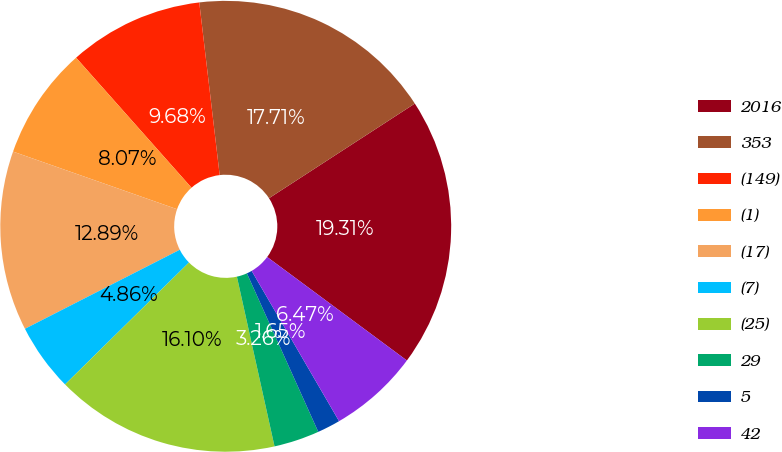<chart> <loc_0><loc_0><loc_500><loc_500><pie_chart><fcel>2016<fcel>353<fcel>(149)<fcel>(1)<fcel>(17)<fcel>(7)<fcel>(25)<fcel>29<fcel>5<fcel>42<nl><fcel>19.31%<fcel>17.71%<fcel>9.68%<fcel>8.07%<fcel>12.89%<fcel>4.86%<fcel>16.1%<fcel>3.26%<fcel>1.65%<fcel>6.47%<nl></chart> 